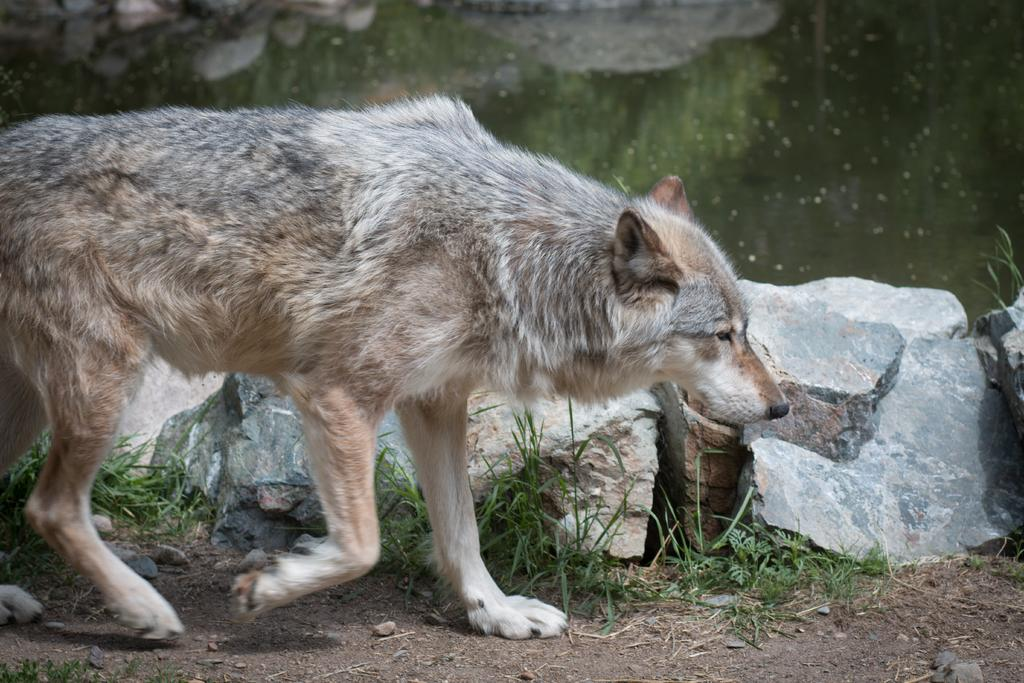What type of animal can be seen in the image? There is an animal in the image, but its specific type cannot be determined from the provided facts. What is the primary element visible in the image? Water is visible in the image. What can be seen on the ground in the image? The ground is visible in the image, with grass and rocks. What is reflected in the water? There is a reflection in the water, but its content cannot be determined from the provided facts. What type of jewel can be seen glued to the animal's line in the image? There is no jewel, glue, or line present in the image. 